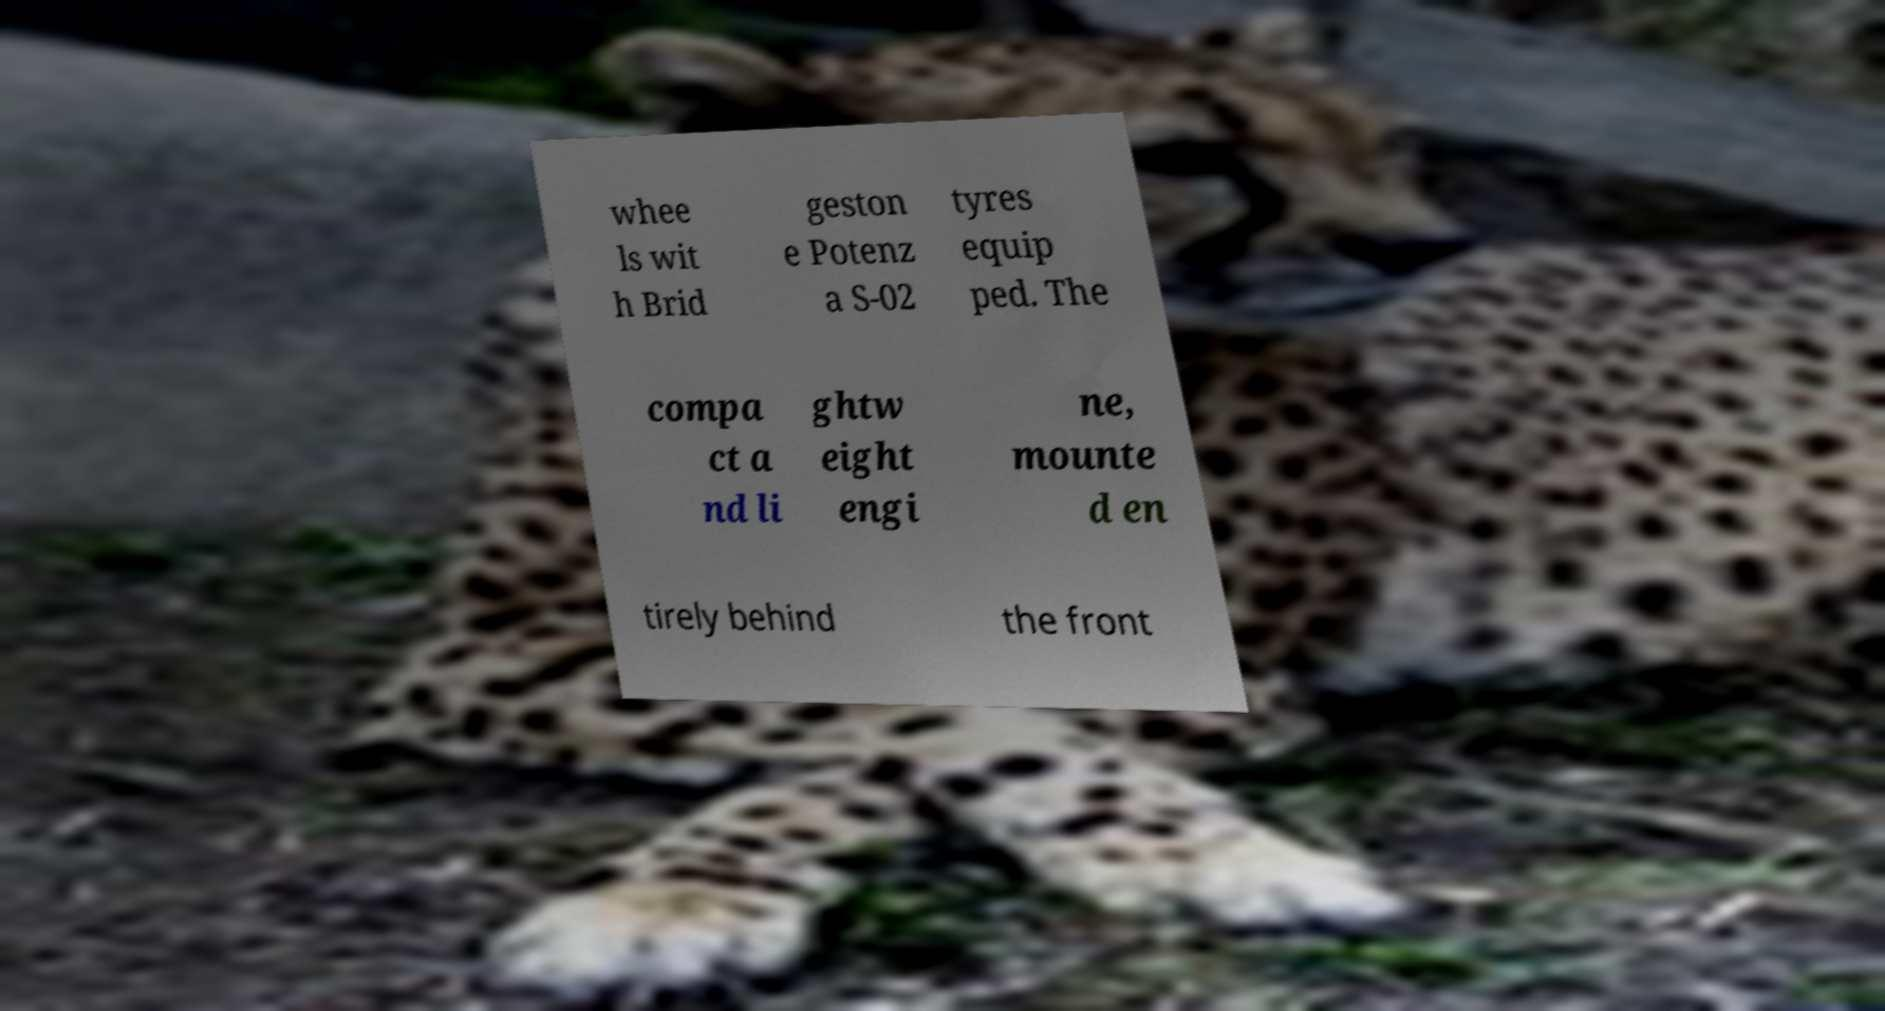Can you accurately transcribe the text from the provided image for me? whee ls wit h Brid geston e Potenz a S-02 tyres equip ped. The compa ct a nd li ghtw eight engi ne, mounte d en tirely behind the front 